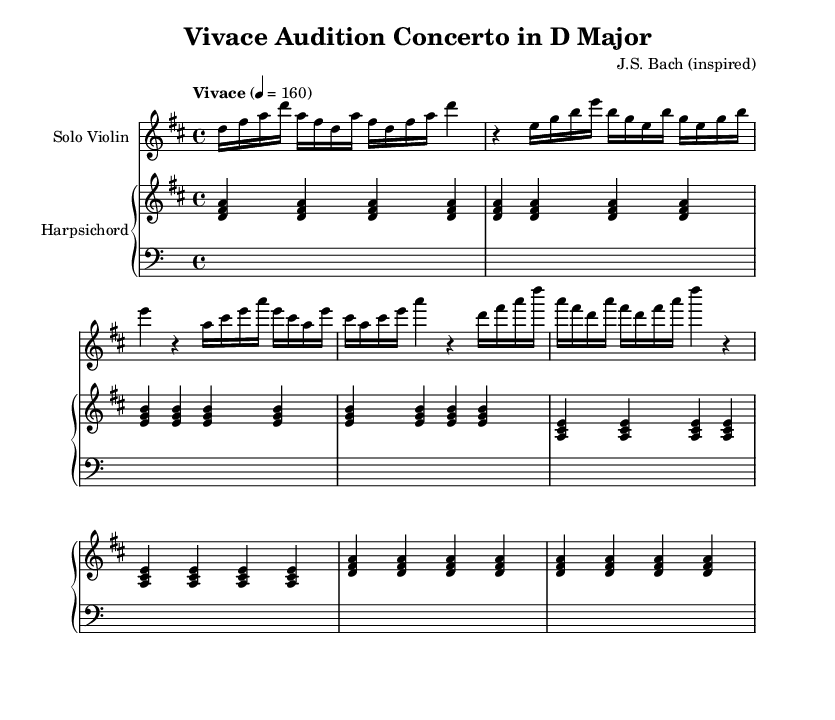What is the key signature of this music? The key signature is D major, which has two sharps: F# and C#.
Answer: D major What is the time signature of the piece? The time signature is 4/4, indicating four beats per measure.
Answer: 4/4 What is the tempo marking for this concerto? The tempo marking is "Vivace," suggesting a lively and brisk pace.
Answer: Vivace How many measures are in the harpsichord part? The harpsichord part contains 8 measures, as indicated by the repeated sections of music.
Answer: 8 What is the primary instrument for the solo part? The primary instrument for the solo part is the violin, as labeled at the beginning of the score.
Answer: Violin Which intervals are primarily used in the violin solo? The violin solo primarily uses sixths, as noted by the melodic movement between adjacent notes in the context of the key.
Answer: Sixths What characterizes the texture of this Baroque concerto? The texture is characterized by a homophonic style, featuring the solo violin prominently with accompaniment from the harpsichord.
Answer: Homophonic 